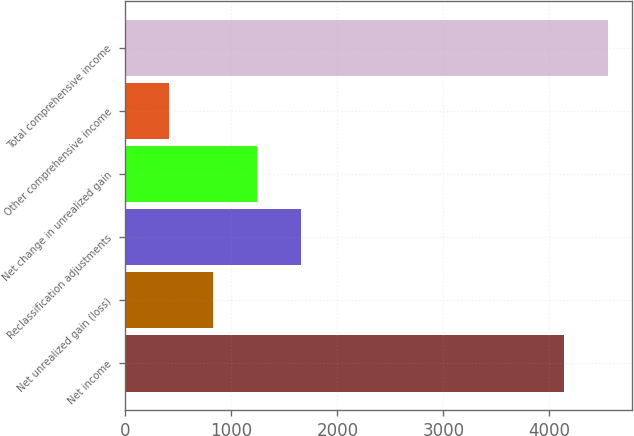<chart> <loc_0><loc_0><loc_500><loc_500><bar_chart><fcel>Net income<fcel>Net unrealized gain (loss)<fcel>Reclassification adjustments<fcel>Net change in unrealized gain<fcel>Other comprehensive income<fcel>Total comprehensive income<nl><fcel>4141<fcel>830.2<fcel>1659.4<fcel>1244.8<fcel>415.6<fcel>4555.6<nl></chart> 